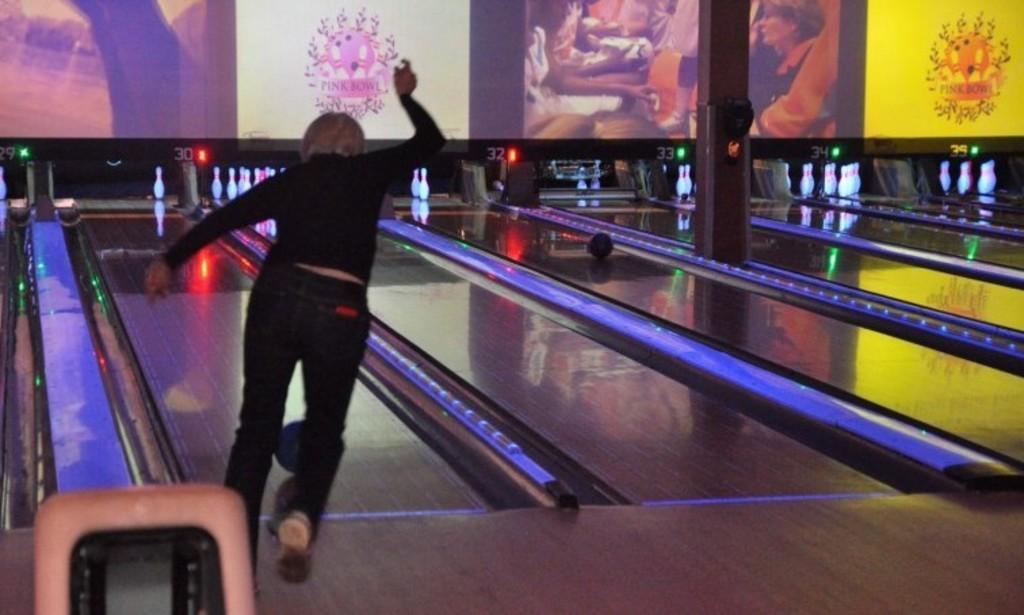In one or two sentences, can you explain what this image depicts? There is a lady playing a bowling and lounge game. There is a ball. In the back there are some pictures on the wall. 